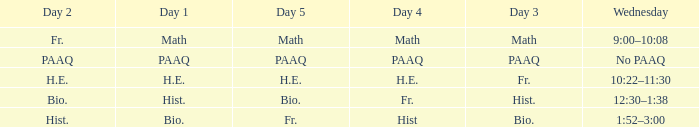What is the Wednesday when day 3 is math? 9:00–10:08. 